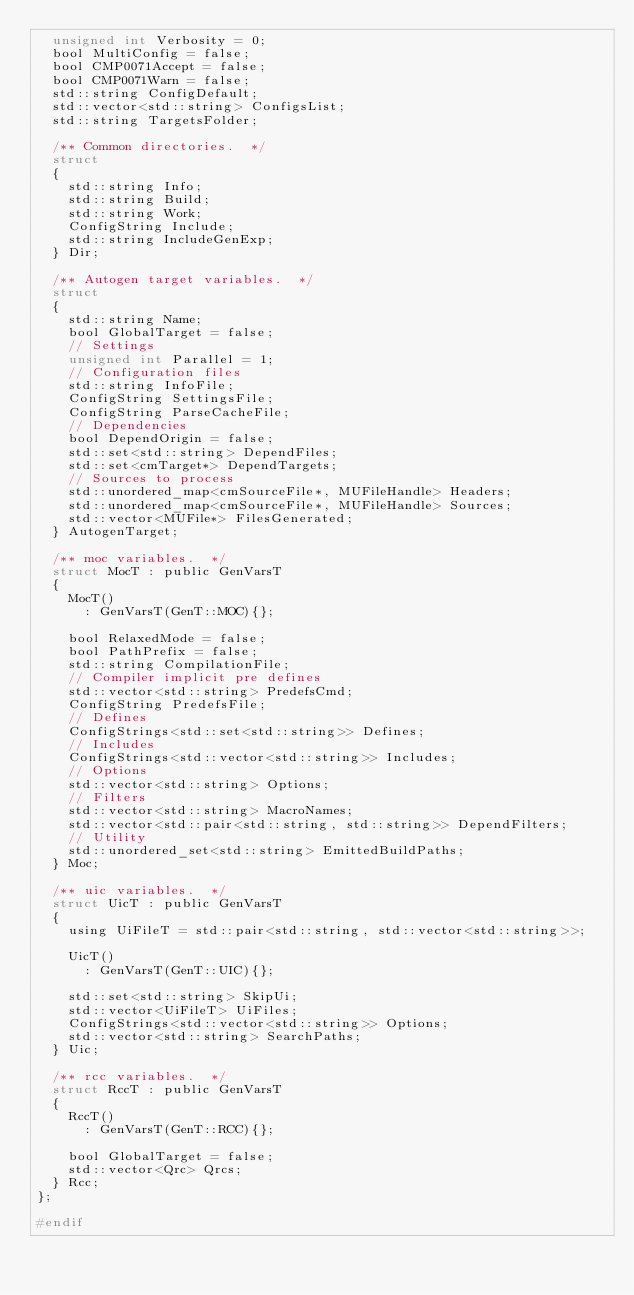<code> <loc_0><loc_0><loc_500><loc_500><_C_>  unsigned int Verbosity = 0;
  bool MultiConfig = false;
  bool CMP0071Accept = false;
  bool CMP0071Warn = false;
  std::string ConfigDefault;
  std::vector<std::string> ConfigsList;
  std::string TargetsFolder;

  /** Common directories.  */
  struct
  {
    std::string Info;
    std::string Build;
    std::string Work;
    ConfigString Include;
    std::string IncludeGenExp;
  } Dir;

  /** Autogen target variables.  */
  struct
  {
    std::string Name;
    bool GlobalTarget = false;
    // Settings
    unsigned int Parallel = 1;
    // Configuration files
    std::string InfoFile;
    ConfigString SettingsFile;
    ConfigString ParseCacheFile;
    // Dependencies
    bool DependOrigin = false;
    std::set<std::string> DependFiles;
    std::set<cmTarget*> DependTargets;
    // Sources to process
    std::unordered_map<cmSourceFile*, MUFileHandle> Headers;
    std::unordered_map<cmSourceFile*, MUFileHandle> Sources;
    std::vector<MUFile*> FilesGenerated;
  } AutogenTarget;

  /** moc variables.  */
  struct MocT : public GenVarsT
  {
    MocT()
      : GenVarsT(GenT::MOC){};

    bool RelaxedMode = false;
    bool PathPrefix = false;
    std::string CompilationFile;
    // Compiler implicit pre defines
    std::vector<std::string> PredefsCmd;
    ConfigString PredefsFile;
    // Defines
    ConfigStrings<std::set<std::string>> Defines;
    // Includes
    ConfigStrings<std::vector<std::string>> Includes;
    // Options
    std::vector<std::string> Options;
    // Filters
    std::vector<std::string> MacroNames;
    std::vector<std::pair<std::string, std::string>> DependFilters;
    // Utility
    std::unordered_set<std::string> EmittedBuildPaths;
  } Moc;

  /** uic variables.  */
  struct UicT : public GenVarsT
  {
    using UiFileT = std::pair<std::string, std::vector<std::string>>;

    UicT()
      : GenVarsT(GenT::UIC){};

    std::set<std::string> SkipUi;
    std::vector<UiFileT> UiFiles;
    ConfigStrings<std::vector<std::string>> Options;
    std::vector<std::string> SearchPaths;
  } Uic;

  /** rcc variables.  */
  struct RccT : public GenVarsT
  {
    RccT()
      : GenVarsT(GenT::RCC){};

    bool GlobalTarget = false;
    std::vector<Qrc> Qrcs;
  } Rcc;
};

#endif
</code> 